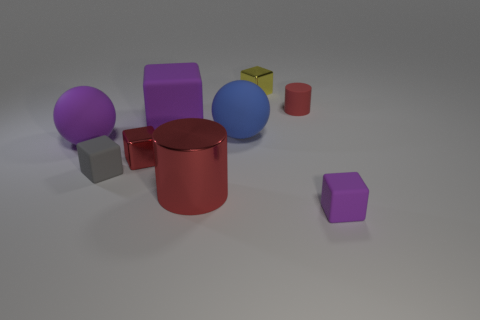The red matte object that is the same size as the yellow thing is what shape?
Give a very brief answer. Cylinder. Are there any other things that have the same color as the rubber cylinder?
Offer a very short reply. Yes. What number of small rubber blocks are there?
Provide a succinct answer. 2. There is a metal thing that is in front of the small yellow block and behind the large red object; what is its shape?
Ensure brevity in your answer.  Cube. There is a matte object that is behind the purple matte cube that is behind the cube that is right of the yellow object; what shape is it?
Offer a very short reply. Cylinder. The small object that is both to the right of the yellow object and behind the small purple block is made of what material?
Keep it short and to the point. Rubber. What number of metal objects are the same size as the blue ball?
Your answer should be compact. 1. What number of shiny things are either tiny blocks or big blue things?
Your answer should be compact. 2. What material is the small gray block?
Make the answer very short. Rubber. What number of purple rubber blocks are on the left side of the blue matte ball?
Keep it short and to the point. 1. 